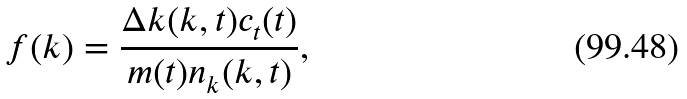Convert formula to latex. <formula><loc_0><loc_0><loc_500><loc_500>f ( k ) = \frac { \Delta k ( k , t ) c _ { t } ( t ) } { m ( t ) n _ { k } ( k , t ) } ,</formula> 